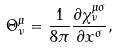<formula> <loc_0><loc_0><loc_500><loc_500>\Theta ^ { \mu } _ { \nu } = \frac { 1 } { 8 \pi } \frac { \partial \chi ^ { \mu \sigma } _ { \nu } } { \partial x ^ { \sigma } } ,</formula> 